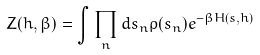<formula> <loc_0><loc_0><loc_500><loc_500>Z ( h , \beta ) = \int \prod _ { n } d s _ { n } \rho ( s _ { n } ) e ^ { - \beta H ( s , h ) }</formula> 